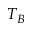Convert formula to latex. <formula><loc_0><loc_0><loc_500><loc_500>T _ { B }</formula> 